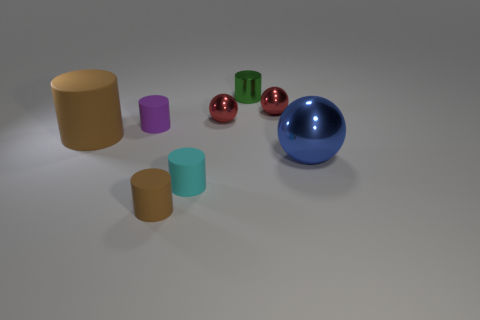Are there the same number of large brown rubber things to the right of the small brown rubber thing and large balls?
Keep it short and to the point. No. Is there anything else that is the same material as the tiny cyan cylinder?
Provide a short and direct response. Yes. How many tiny things are either blue objects or brown matte cylinders?
Your answer should be compact. 1. There is a tiny matte object that is the same color as the big matte thing; what is its shape?
Keep it short and to the point. Cylinder. Is the brown thing behind the small brown thing made of the same material as the small cyan cylinder?
Offer a terse response. Yes. There is a brown object behind the shiny sphere in front of the large cylinder; what is it made of?
Provide a short and direct response. Rubber. What number of other objects have the same shape as the purple thing?
Make the answer very short. 4. What is the size of the green metal object behind the brown matte cylinder in front of the brown object that is on the left side of the tiny purple matte cylinder?
Make the answer very short. Small. How many yellow objects are either big balls or large matte cylinders?
Give a very brief answer. 0. There is a brown object on the right side of the large rubber cylinder; is it the same shape as the cyan object?
Provide a short and direct response. Yes. 